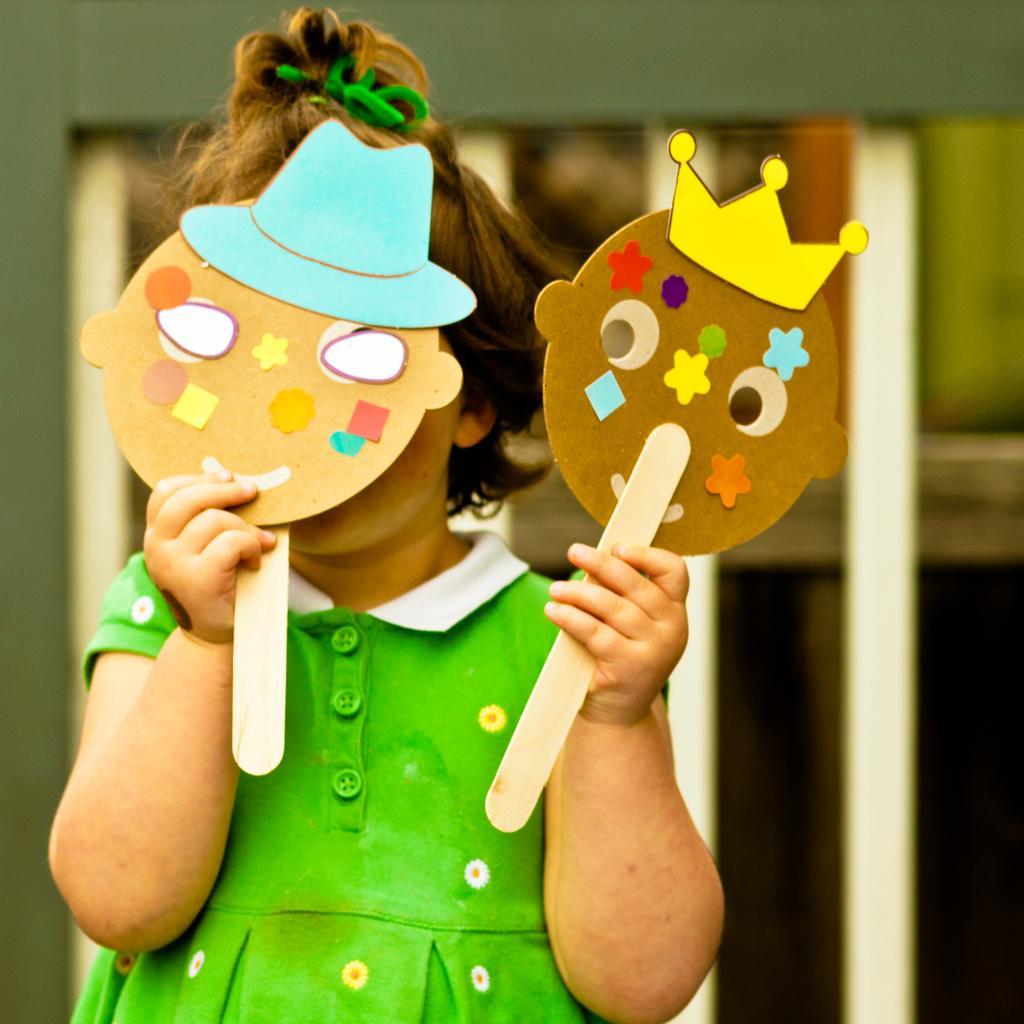Can you describe this image briefly? In this image we can see a child holding two boards with some stickers pasted on it. On the backside we can see a wall. 